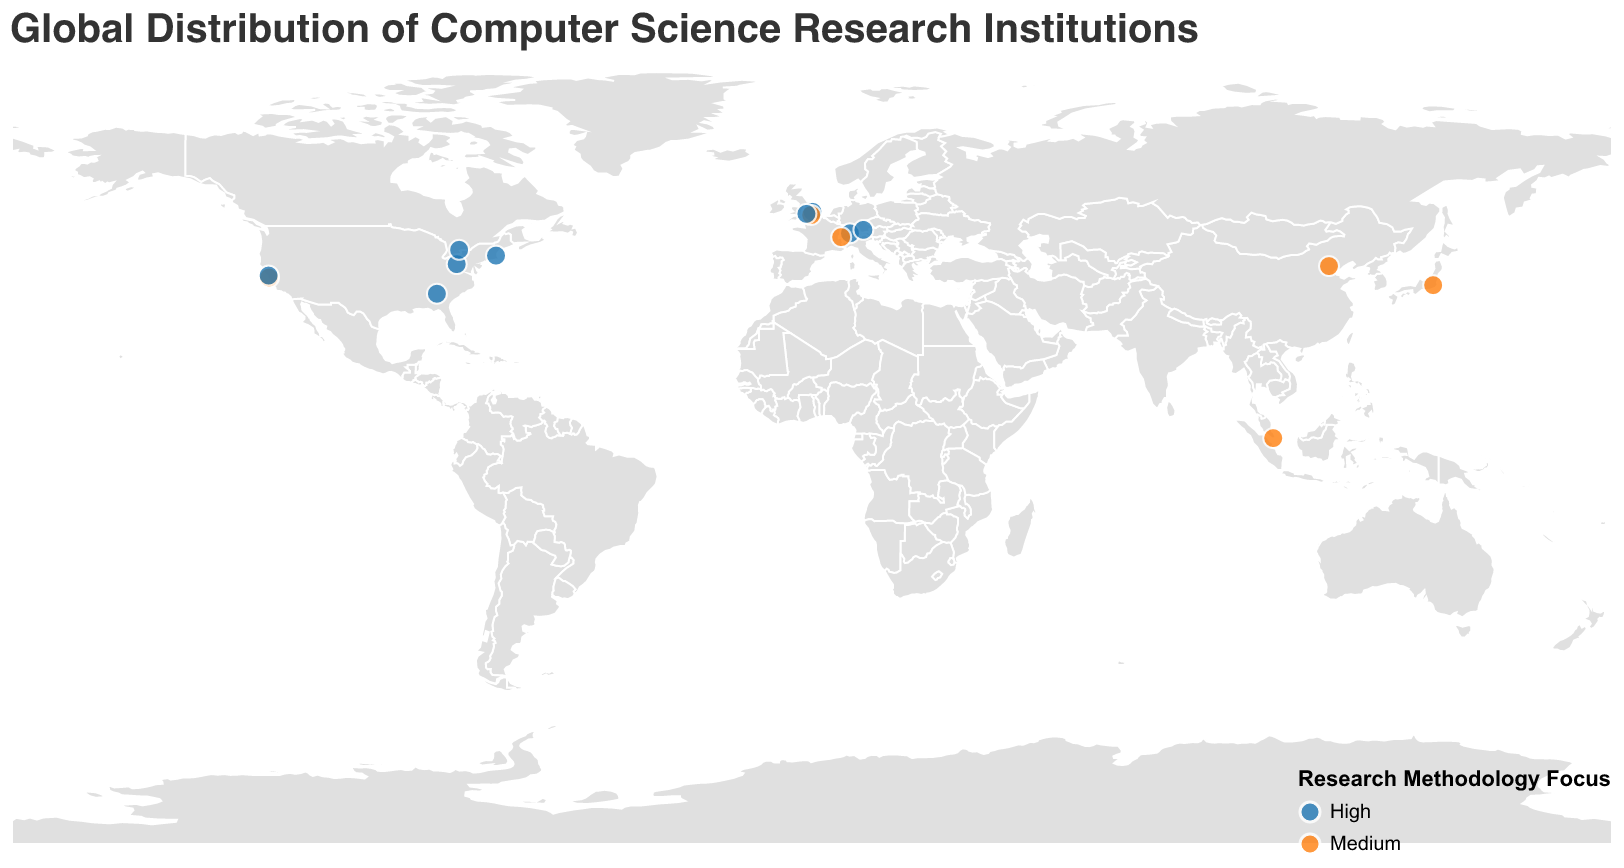What is the title of the plot? The title is usually indicated at the top of the plot. Here, it is given in the code as well: "Global Distribution of Computer Science Research Institutions"
Answer: Global Distribution of Computer Science Research Institutions How many institutions have a high focus on research methodology? Count the number of institutions marked with "High" under "Research_Methodology_Focus". This can be seen by observing the plot's legend and associated colors.
Answer: 9 What specialization is the University of Tokyo known for? Locate the University of Tokyo on the map, check its tooltip to see its specialization.
Answer: Quantum Computing Which region has the highest concentration of research institutions with high methodological focus? Observing the distribution of the blue-colored markers (indicating high methodology focus) on the map, it can be seen that North America has a higher concentration of these institutions.
Answer: North America Which university focuses on Computer Vision? By checking the tooltips on the plot, locate the university labeled "Computer Vision".
Answer: Stanford University How many institutions on the plot specialize in Artificial Intelligence? Identify the tooltip for each institution to count how many have "Artificial Intelligence" under "Specialization".
Answer: 1 Compare the research methodology focus between National University of Singapore and Carnegie Mellon University. National University of Singapore is marked in orange (Medium focus), while Carnegie Mellon University is in blue (High focus).
Answer: National University of Singapore: Medium, Carnegie Mellon University: High If you group the institutions by their research methodology focus, which group has more data points, High or Medium? Count the circles corresponding to each color representing "High" and "Medium" focus respectively. "High" is represented by blue and "Medium" by orange. The count can be verified as more blue circles on the map.
Answer: High Which institution is located closest to the equator? On examining the plot, the National University of Singapore appears closest to the equator based on its latitude value.
Answer: National University of Singapore What specializations can be found in the United States? Look at the institutions within the United States and check their tooltip descriptors for specialization.
Answer: Artificial Intelligence, Computer Vision, Machine Learning, Distributed Systems, Human-Computer Interaction 